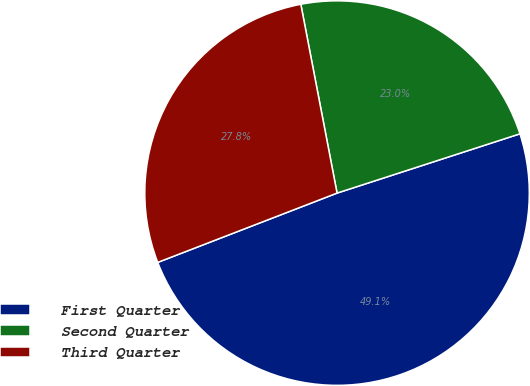Convert chart. <chart><loc_0><loc_0><loc_500><loc_500><pie_chart><fcel>First Quarter<fcel>Second Quarter<fcel>Third Quarter<nl><fcel>49.12%<fcel>23.03%<fcel>27.85%<nl></chart> 